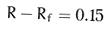<formula> <loc_0><loc_0><loc_500><loc_500>R - R _ { f } = 0 . 1 5</formula> 